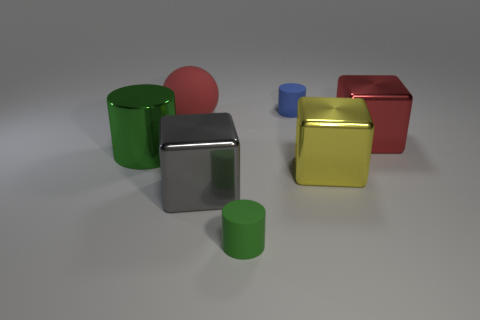Is the number of small green rubber cylinders in front of the big red metallic thing greater than the number of gray blocks in front of the gray cube?
Provide a short and direct response. Yes. How many blue things are in front of the red thing behind the big red block?
Offer a terse response. 0. How many things are large matte spheres or cylinders?
Offer a terse response. 4. Does the blue rubber thing have the same shape as the big green metallic object?
Ensure brevity in your answer.  Yes. What is the large red cube made of?
Offer a terse response. Metal. How many rubber things are in front of the blue matte cylinder and on the right side of the large red ball?
Your answer should be very brief. 1. Do the red metallic cube and the shiny cylinder have the same size?
Provide a short and direct response. Yes. There is a cylinder left of the red matte ball; does it have the same size as the yellow block?
Offer a terse response. Yes. The tiny object that is in front of the red sphere is what color?
Provide a short and direct response. Green. How many green metal blocks are there?
Make the answer very short. 0. 